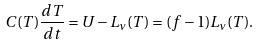<formula> <loc_0><loc_0><loc_500><loc_500>C ( T ) \frac { d T } { d t } = U - L _ { \nu } ( T ) = ( f - 1 ) L _ { \nu } ( T ) .</formula> 